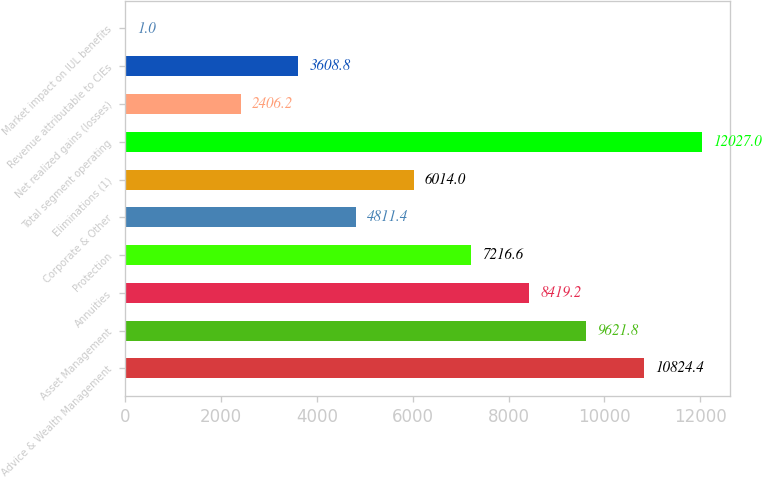Convert chart to OTSL. <chart><loc_0><loc_0><loc_500><loc_500><bar_chart><fcel>Advice & Wealth Management<fcel>Asset Management<fcel>Annuities<fcel>Protection<fcel>Corporate & Other<fcel>Eliminations (1)<fcel>Total segment operating<fcel>Net realized gains (losses)<fcel>Revenue attributable to CIEs<fcel>Market impact on IUL benefits<nl><fcel>10824.4<fcel>9621.8<fcel>8419.2<fcel>7216.6<fcel>4811.4<fcel>6014<fcel>12027<fcel>2406.2<fcel>3608.8<fcel>1<nl></chart> 